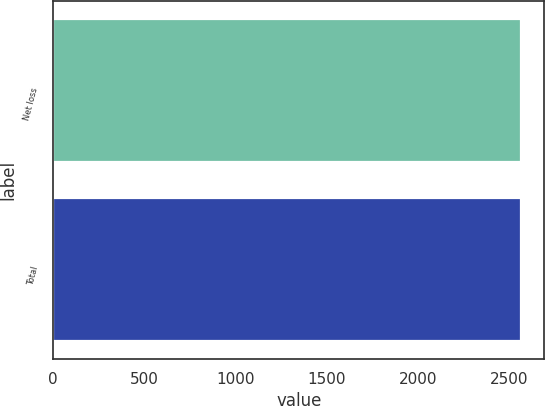Convert chart. <chart><loc_0><loc_0><loc_500><loc_500><bar_chart><fcel>Net loss<fcel>Total<nl><fcel>2563<fcel>2563.1<nl></chart> 